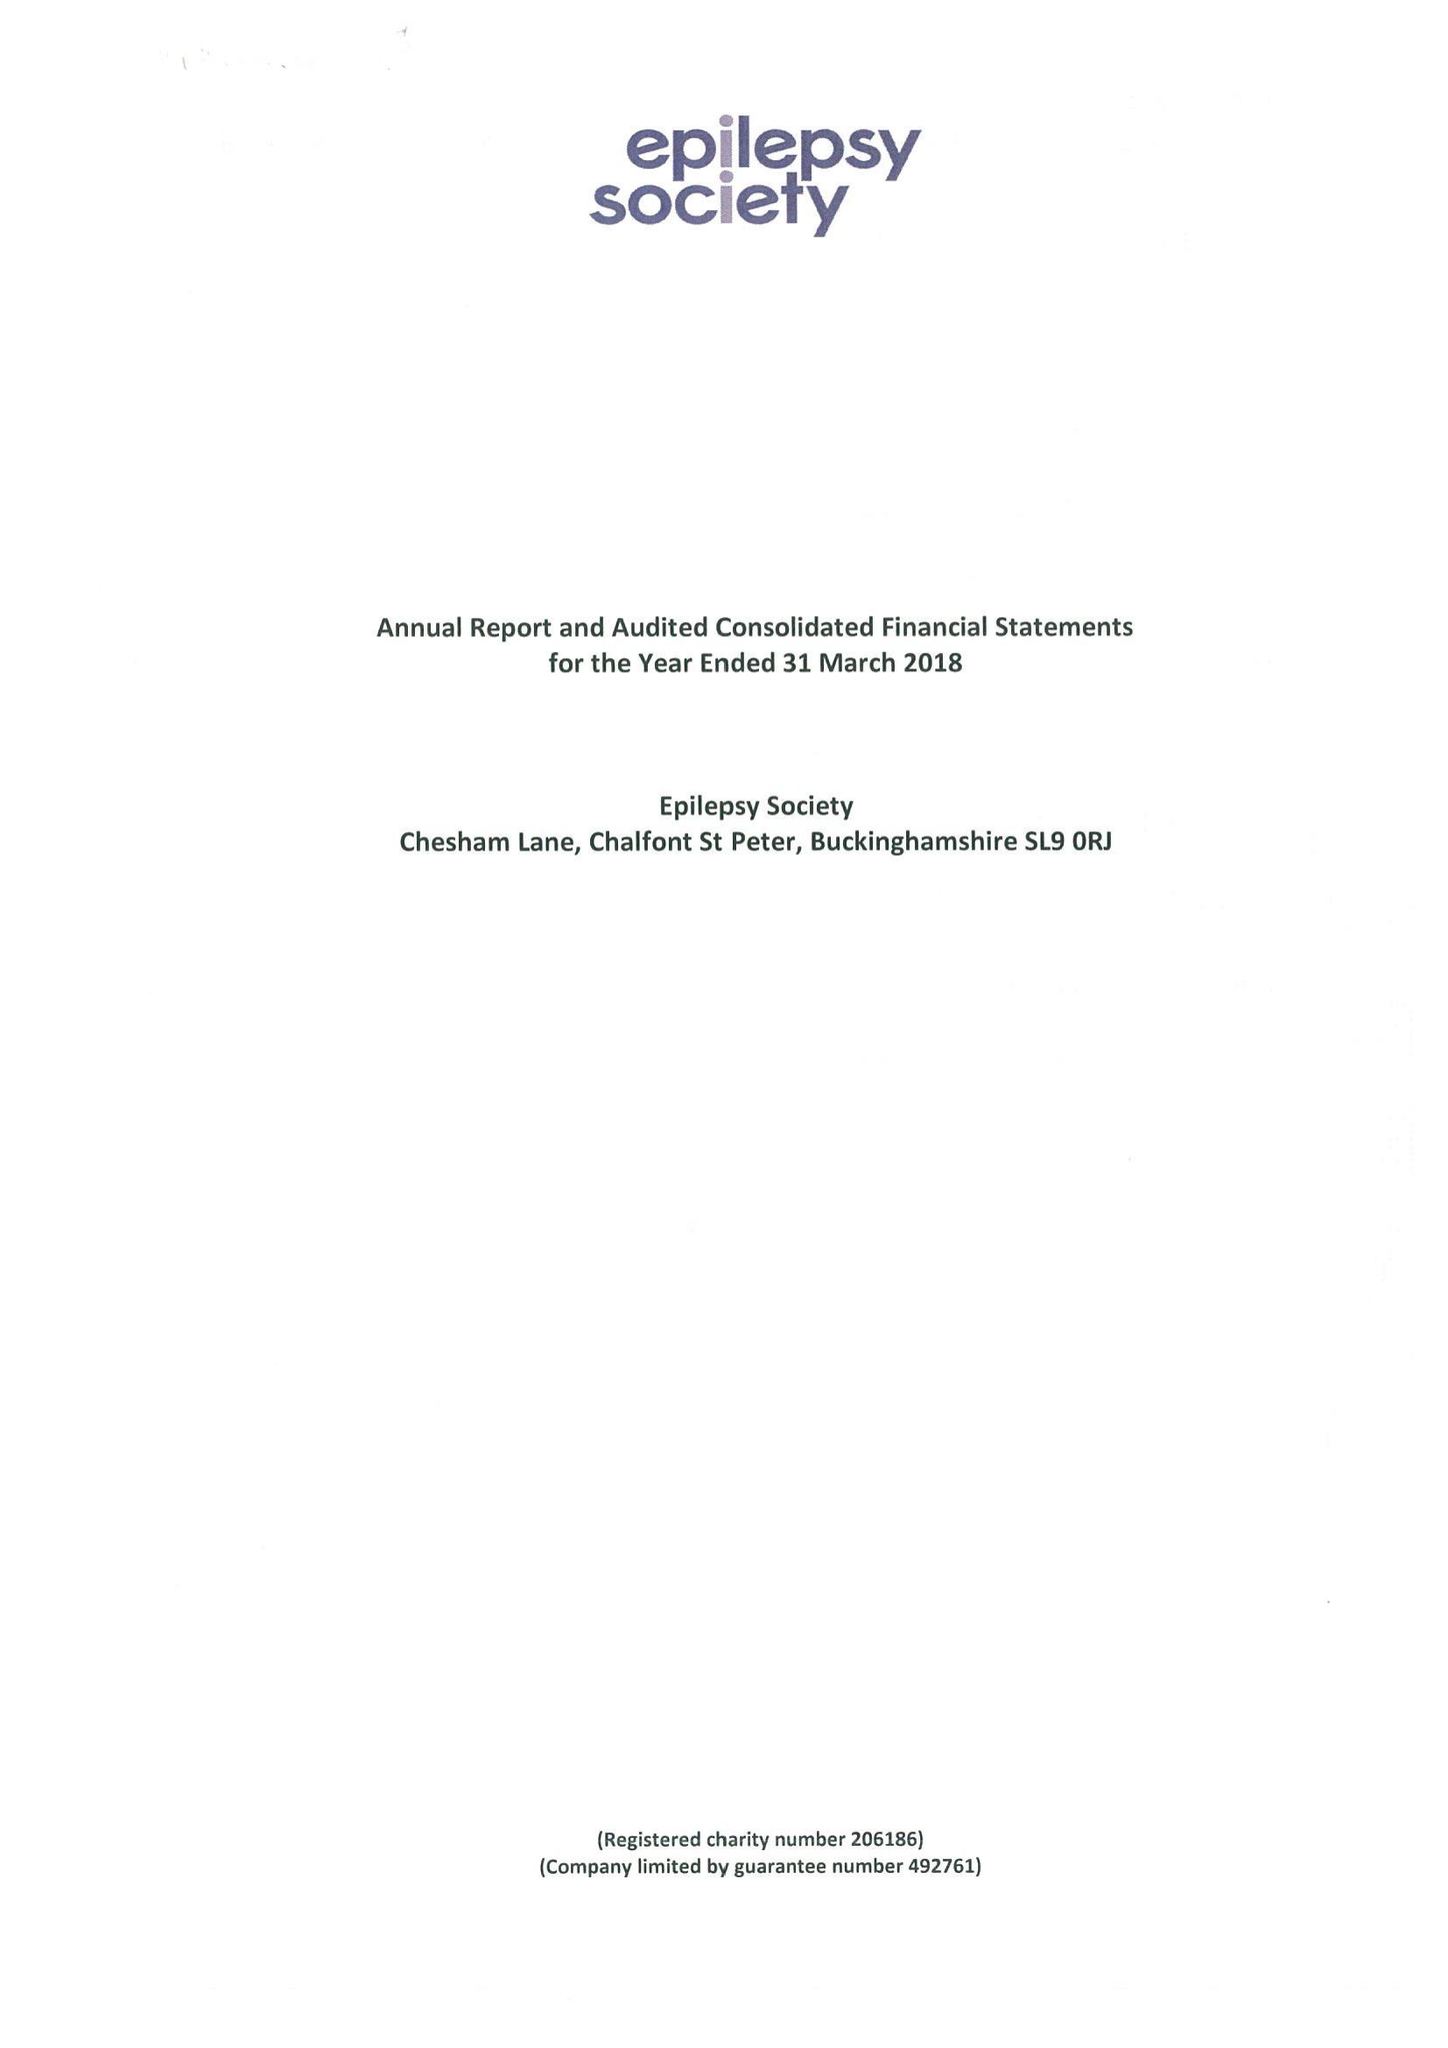What is the value for the address__postcode?
Answer the question using a single word or phrase. SL9 0RJ 